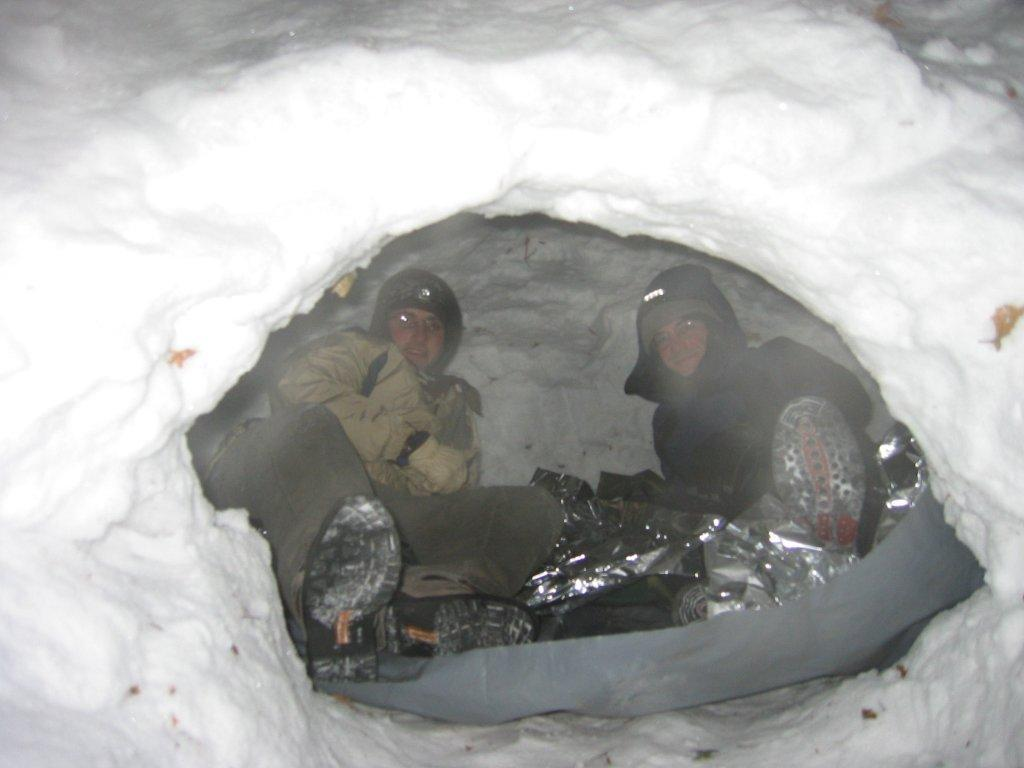How many people are sitting in the image? There are two men sitting in the image. What else can be seen in the image besides the men? There are objects in the image. What is the weather like in the image? Snow is visible in the image, indicating a cold or wintry setting. What type of grass can be seen growing in the cemetery in the image? There is no cemetery present in the image, and therefore no grass can be observed. 